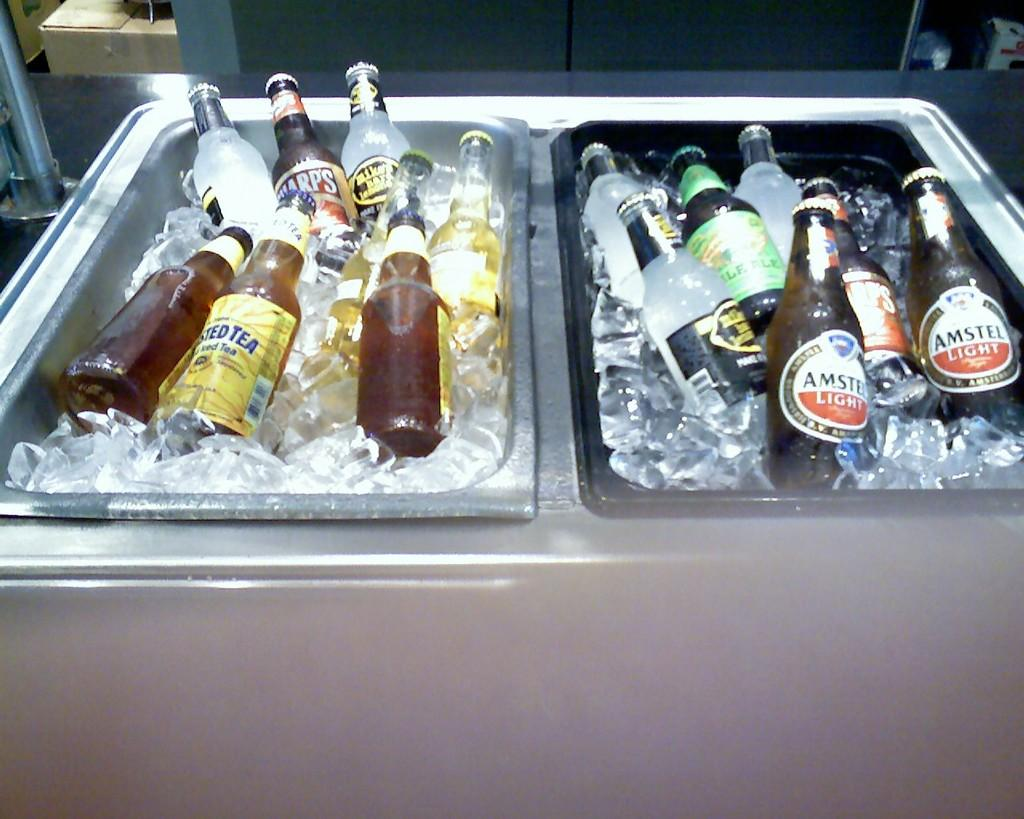What is stored in the container that is visible in the image? There are wine bottles in the image. How are the wine bottles being kept cool? The wine bottles are in ice. What type of surface is the container resting on? There is a table in the image. What type of basin is being used to hold the wine bottles in the image? There is no basin present in the image; the wine bottles are stored in a container. Can you see a road in the image? There is no road visible in the image; it features a container with wine bottles on a table. 